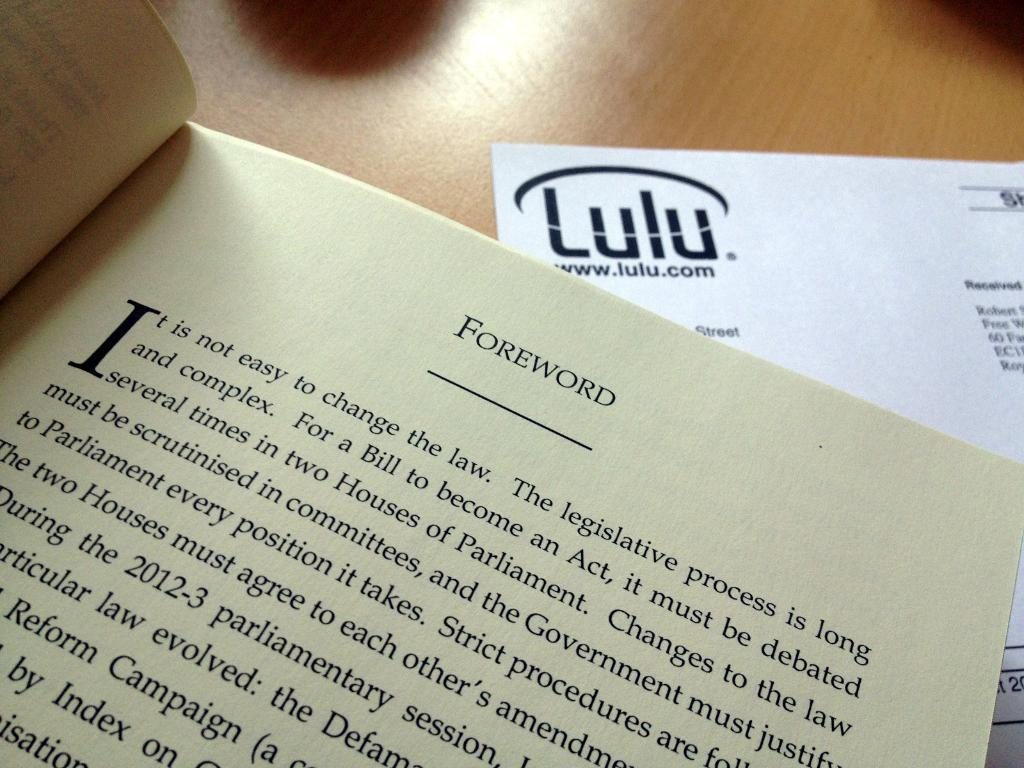<image>
Write a terse but informative summary of the picture. A book is open to a page that says Foreword at the top 